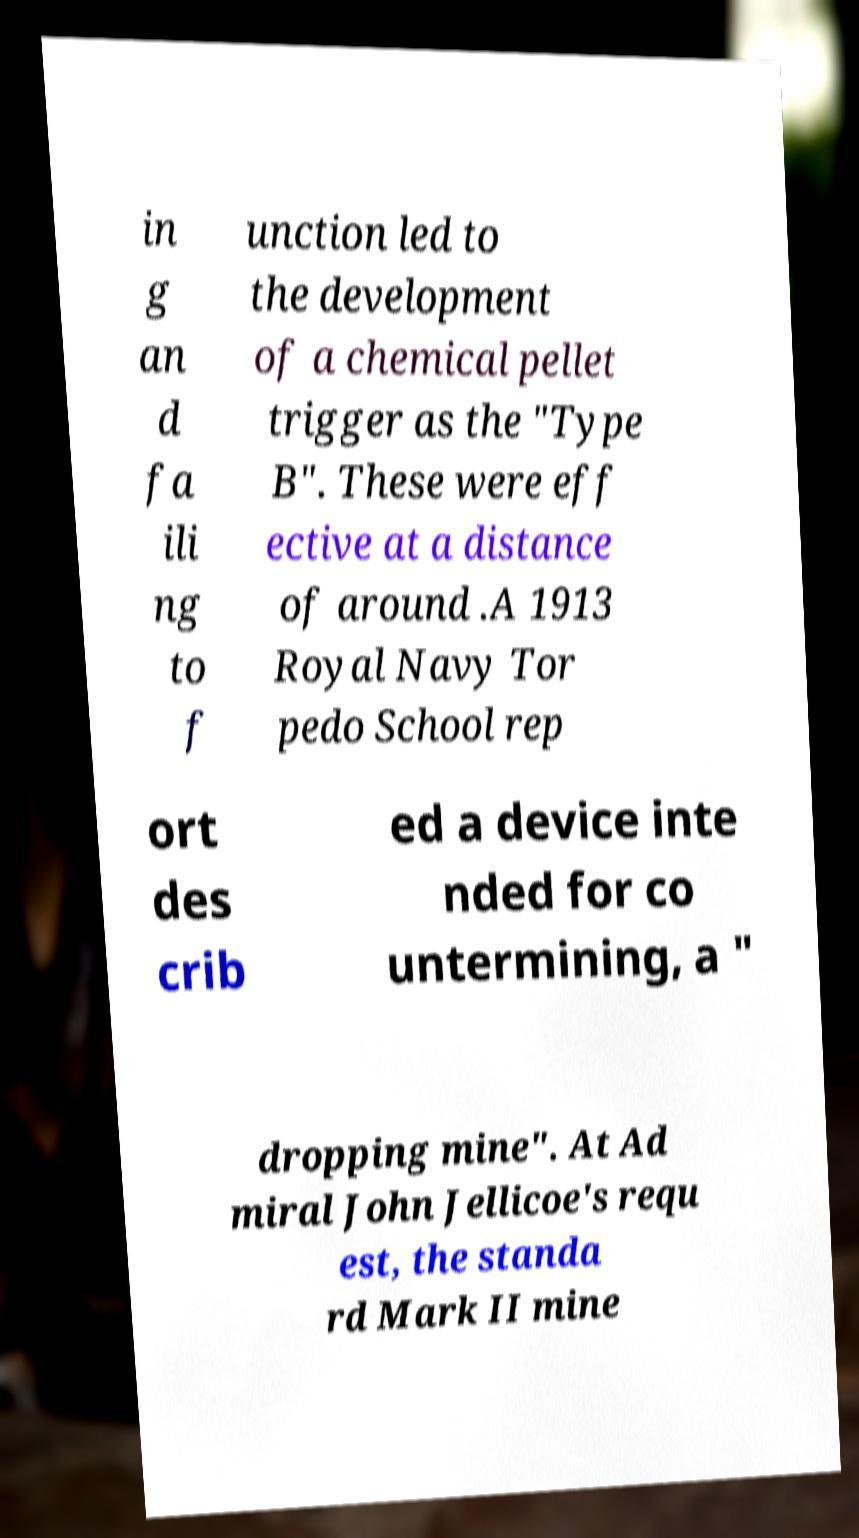For documentation purposes, I need the text within this image transcribed. Could you provide that? in g an d fa ili ng to f unction led to the development of a chemical pellet trigger as the "Type B". These were eff ective at a distance of around .A 1913 Royal Navy Tor pedo School rep ort des crib ed a device inte nded for co untermining, a " dropping mine". At Ad miral John Jellicoe's requ est, the standa rd Mark II mine 